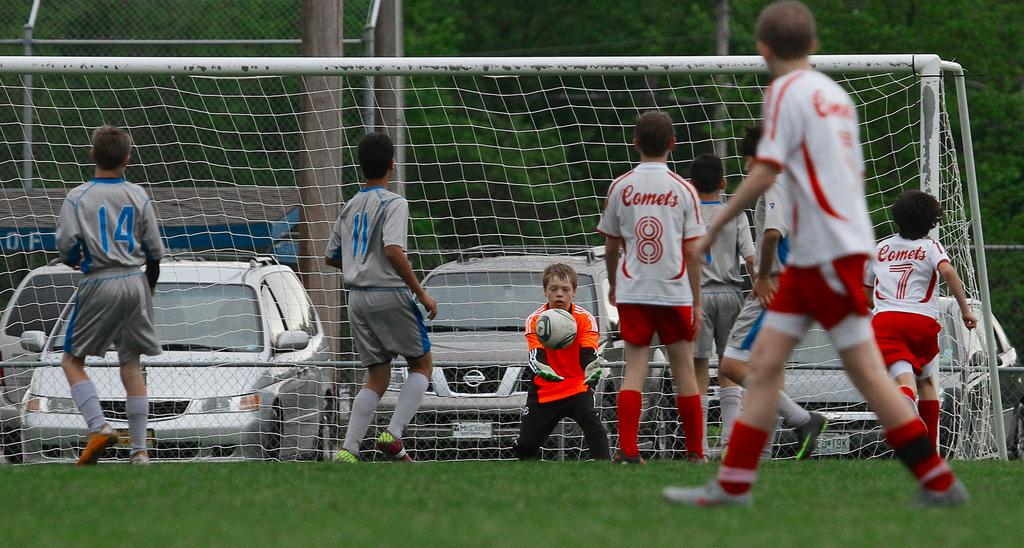What are the people in the image doing? There are persons standing on the ground in the image. Can you describe what one of the persons is holding? One of the persons is holding a ball in his hands. What can be seen in the background of the image? There are trees and motor vehicles visible in the background of the image. What type of wound can be seen on the person holding the ball? There is no wound visible on the person holding the ball in the image. What idea is the person holding the ball trying to convey to the others? The image does not provide any information about the person's ideas or intentions, so we cannot determine what idea they might be trying to convey. 